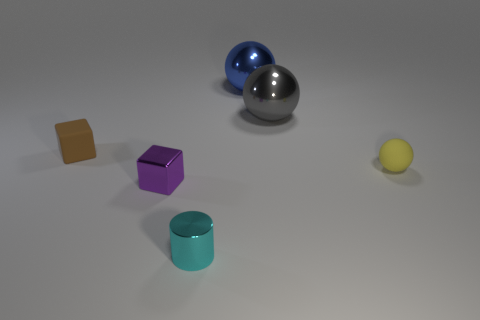Does the rubber object to the left of the small yellow matte thing have the same color as the tiny rubber ball?
Offer a terse response. No. Do the cube behind the yellow matte thing and the small rubber sphere right of the brown cube have the same color?
Your answer should be very brief. No. Are there any large balls made of the same material as the small yellow ball?
Your answer should be compact. No. What number of brown things are either metallic balls or small metallic objects?
Keep it short and to the point. 0. Are there more gray things that are left of the blue ball than blue objects?
Keep it short and to the point. No. Is the gray metallic sphere the same size as the metallic cube?
Your answer should be very brief. No. What is the color of the block that is made of the same material as the tiny cylinder?
Provide a short and direct response. Purple. Are there the same number of small spheres that are on the left side of the tiny matte cube and big blue objects to the left of the purple metal object?
Provide a succinct answer. Yes. The small rubber object that is to the left of the rubber object in front of the brown rubber cube is what shape?
Keep it short and to the point. Cube. What material is the large blue object that is the same shape as the large gray thing?
Give a very brief answer. Metal. 